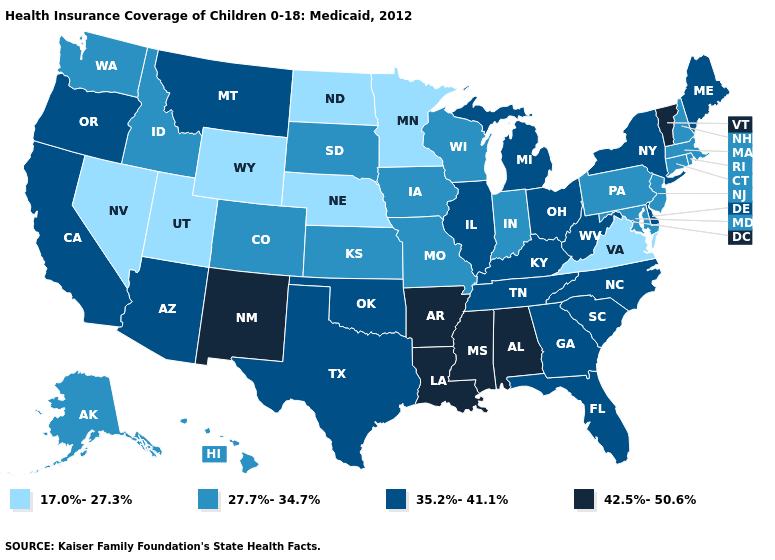Name the states that have a value in the range 35.2%-41.1%?
Give a very brief answer. Arizona, California, Delaware, Florida, Georgia, Illinois, Kentucky, Maine, Michigan, Montana, New York, North Carolina, Ohio, Oklahoma, Oregon, South Carolina, Tennessee, Texas, West Virginia. Does Utah have the lowest value in the West?
Answer briefly. Yes. Does Alaska have a higher value than Nevada?
Be succinct. Yes. What is the value of Utah?
Concise answer only. 17.0%-27.3%. What is the lowest value in the MidWest?
Answer briefly. 17.0%-27.3%. Among the states that border Missouri , which have the lowest value?
Answer briefly. Nebraska. Does New Mexico have the highest value in the USA?
Write a very short answer. Yes. Name the states that have a value in the range 42.5%-50.6%?
Concise answer only. Alabama, Arkansas, Louisiana, Mississippi, New Mexico, Vermont. What is the highest value in the South ?
Concise answer only. 42.5%-50.6%. What is the value of South Carolina?
Keep it brief. 35.2%-41.1%. Which states have the lowest value in the USA?
Answer briefly. Minnesota, Nebraska, Nevada, North Dakota, Utah, Virginia, Wyoming. Does Delaware have the lowest value in the South?
Keep it brief. No. What is the highest value in the West ?
Concise answer only. 42.5%-50.6%. How many symbols are there in the legend?
Be succinct. 4. Name the states that have a value in the range 17.0%-27.3%?
Short answer required. Minnesota, Nebraska, Nevada, North Dakota, Utah, Virginia, Wyoming. 